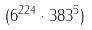<formula> <loc_0><loc_0><loc_500><loc_500>( 6 ^ { 2 2 4 } \cdot 3 8 3 ^ { 5 } )</formula> 